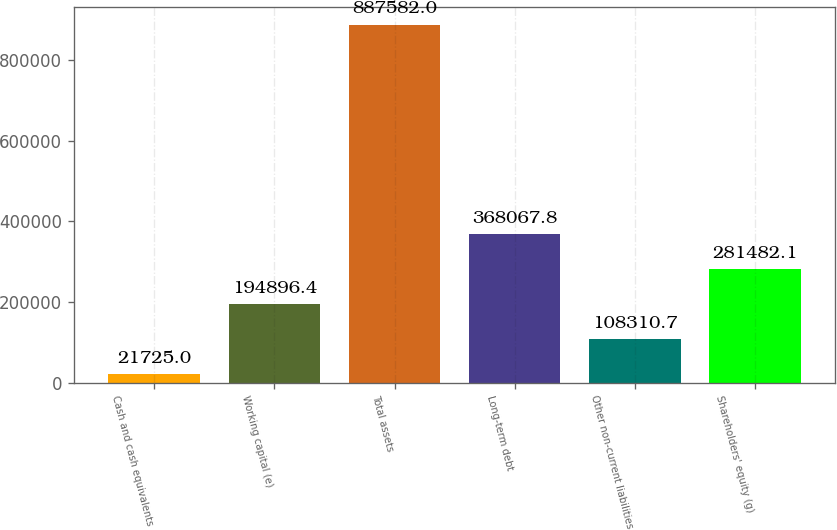<chart> <loc_0><loc_0><loc_500><loc_500><bar_chart><fcel>Cash and cash equivalents<fcel>Working capital (e)<fcel>Total assets<fcel>Long-term debt<fcel>Other non-current liabilities<fcel>Shareholders' equity (g)<nl><fcel>21725<fcel>194896<fcel>887582<fcel>368068<fcel>108311<fcel>281482<nl></chart> 